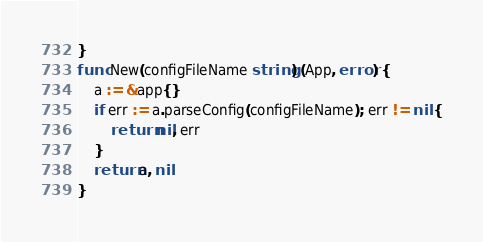<code> <loc_0><loc_0><loc_500><loc_500><_Go_>}
func New(configFileName string) (App, error) {
	a := &app{}
	if err := a.parseConfig(configFileName); err != nil {
		return nil, err
	}
	return a, nil
}
</code> 